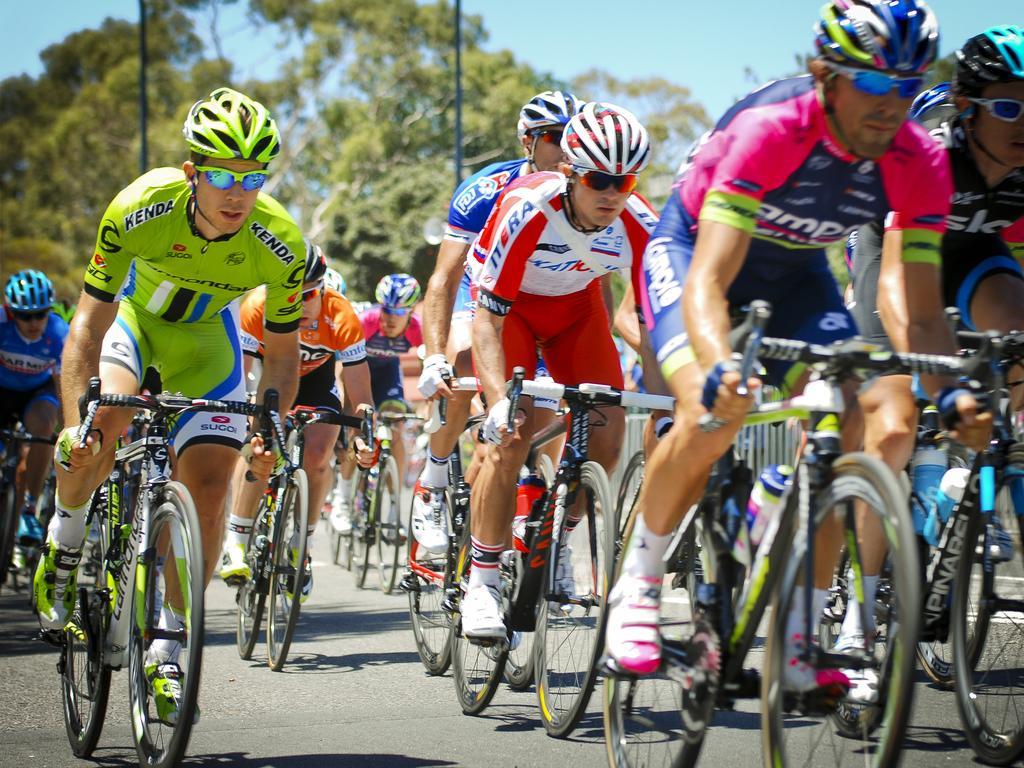Describe this image in one or two sentences. In this image there are group of people with helmets and spectacles are riding their bicycles on the road, and in the background there are trees,sky. 